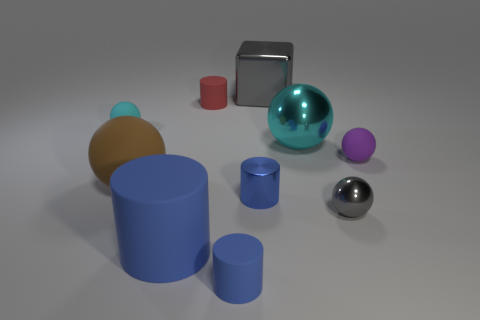Do the shiny sphere right of the big cyan ball and the metallic thing behind the cyan metallic thing have the same color?
Give a very brief answer. Yes. What number of things are in front of the shiny cylinder and left of the small red cylinder?
Your answer should be very brief. 1. Is the gray object that is behind the small cyan object made of the same material as the tiny gray sphere?
Your answer should be compact. Yes. The tiny metallic thing that is on the right side of the gray shiny thing behind the gray shiny object in front of the blue shiny thing is what shape?
Offer a terse response. Sphere. Is the number of large metallic spheres in front of the red matte cylinder the same as the number of metallic balls in front of the large blue thing?
Your answer should be very brief. No. What is the color of the other matte cylinder that is the same size as the red matte cylinder?
Offer a terse response. Blue. How many small things are blue rubber things or purple matte spheres?
Give a very brief answer. 2. There is a sphere that is both right of the brown rubber thing and to the left of the small gray thing; what is its material?
Give a very brief answer. Metal. Is the shape of the cyan thing on the left side of the large blue rubber object the same as the small metal object right of the small metal cylinder?
Ensure brevity in your answer.  Yes. The large thing that is the same color as the shiny cylinder is what shape?
Keep it short and to the point. Cylinder. 